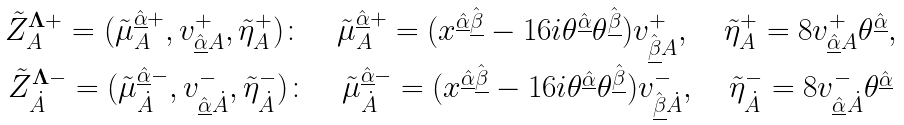Convert formula to latex. <formula><loc_0><loc_0><loc_500><loc_500>\begin{array} { c } \tilde { Z } ^ { \mathbf \Lambda + } _ { A } = ( \tilde { \mu } ^ { \hat { \underline { \alpha } } + } _ { A } , v ^ { + } _ { \hat { \underline { \alpha } } A } , \tilde { \eta } ^ { + } _ { A } ) \colon \quad \tilde { \mu } ^ { \hat { \underline { \alpha } } + } _ { A } = ( x ^ { \hat { \underline { \alpha } } \hat { \underline { \beta } } } - 1 6 i \theta ^ { \hat { \underline { \alpha } } } \theta ^ { \hat { \underline { \beta } } } ) v _ { \hat { \underline { \beta } } A } ^ { + } , \quad \tilde { \eta } ^ { + } _ { A } = 8 v _ { \hat { \underline { \alpha } } A } ^ { + } \theta ^ { \hat { \underline { \alpha } } } , \\ \tilde { Z } ^ { \mathbf \Lambda - } _ { \dot { A } } = ( \tilde { \mu } ^ { \hat { \underline { \alpha } } - } _ { \dot { A } } , v ^ { - } _ { \hat { \underline { \alpha } } \dot { A } } , \tilde { \eta } ^ { - } _ { \dot { A } } ) \colon \quad \tilde { \mu } ^ { \hat { \underline { \alpha } } - } _ { \dot { A } } = ( x ^ { \hat { \underline { \alpha } } \hat { \underline { \beta } } } - 1 6 i \theta ^ { \hat { \underline { \alpha } } } \theta ^ { \hat { \underline { \beta } } } ) v _ { \hat { \underline { \beta } } \dot { A } } ^ { - } , \quad \tilde { \eta } ^ { - } _ { \dot { A } } = 8 v _ { \hat { \underline { \alpha } } \dot { A } } ^ { - } \theta ^ { \hat { \underline { \alpha } } } \end{array}</formula> 